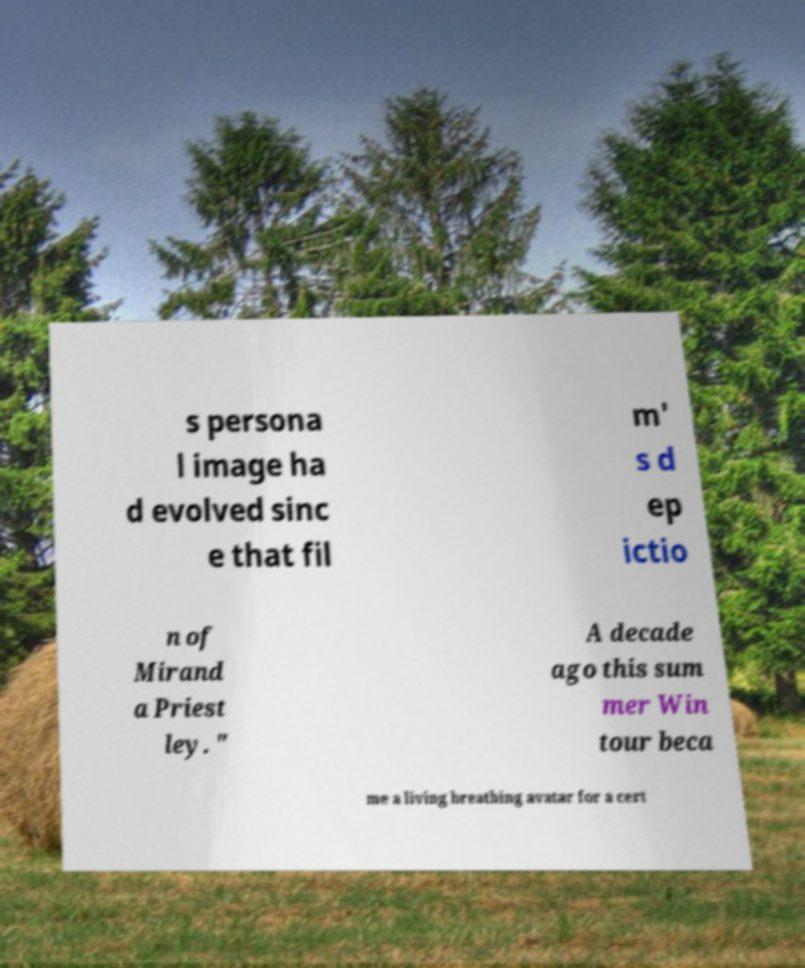There's text embedded in this image that I need extracted. Can you transcribe it verbatim? s persona l image ha d evolved sinc e that fil m' s d ep ictio n of Mirand a Priest ley. " A decade ago this sum mer Win tour beca me a living breathing avatar for a cert 